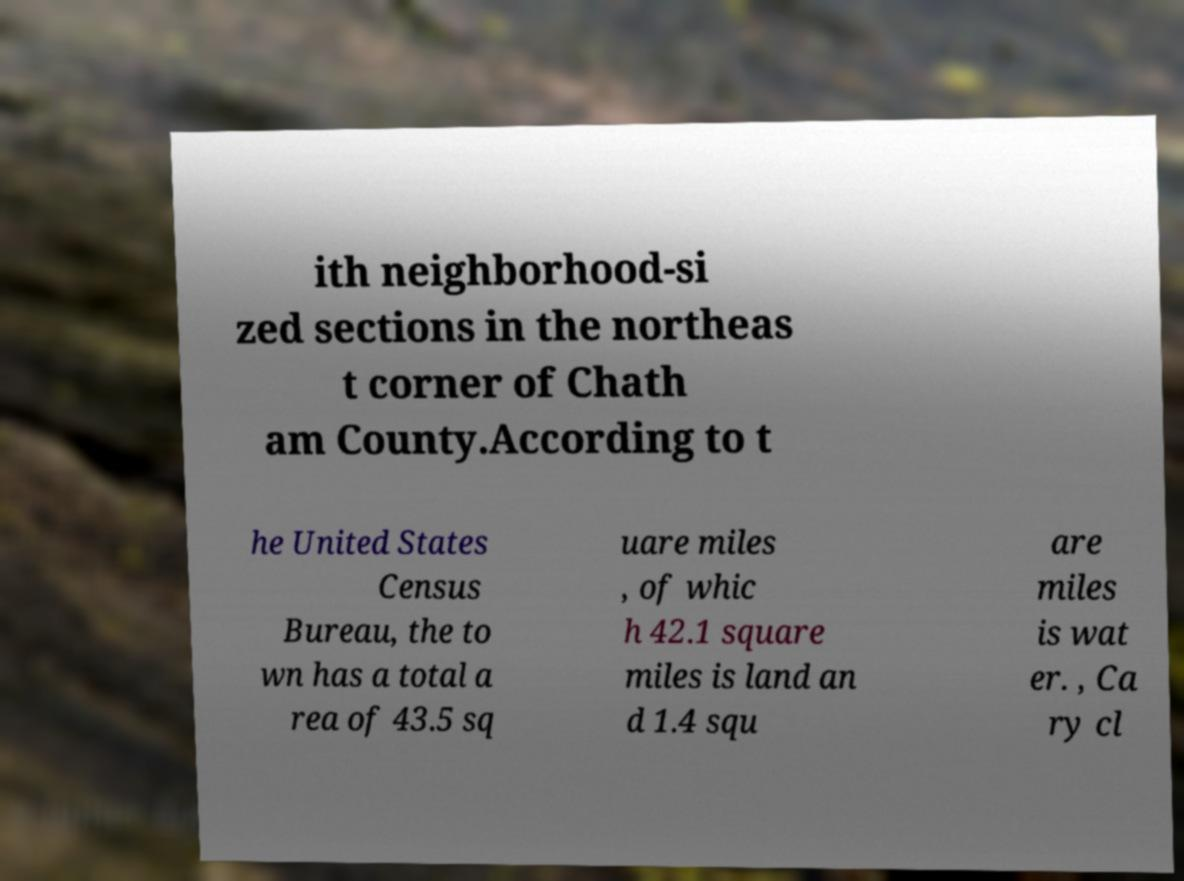There's text embedded in this image that I need extracted. Can you transcribe it verbatim? ith neighborhood-si zed sections in the northeas t corner of Chath am County.According to t he United States Census Bureau, the to wn has a total a rea of 43.5 sq uare miles , of whic h 42.1 square miles is land an d 1.4 squ are miles is wat er. , Ca ry cl 